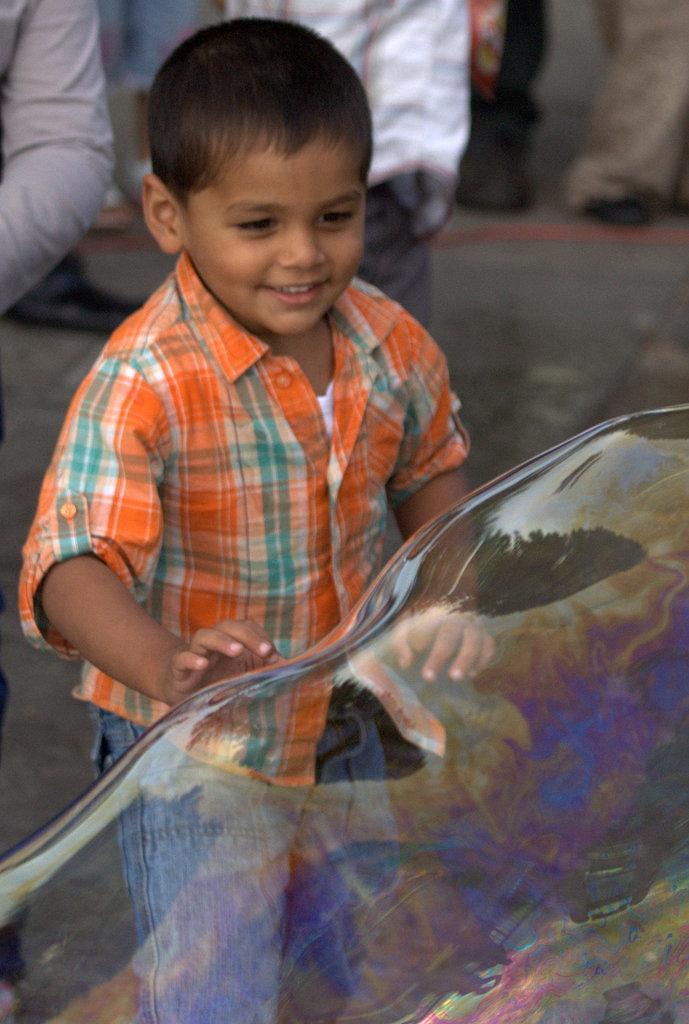Can you describe this image briefly? In this image we can see a boy wearing the shirt and standing. We can also see the soap bubble. In the background there are some people on the path. 